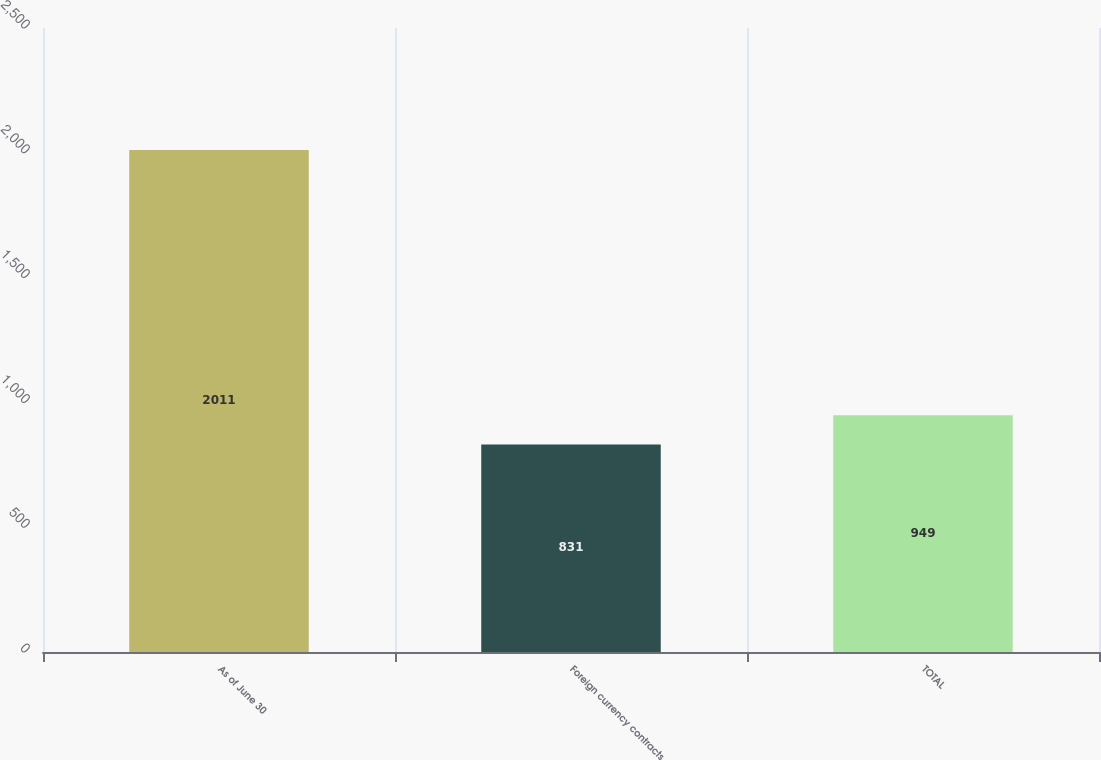Convert chart. <chart><loc_0><loc_0><loc_500><loc_500><bar_chart><fcel>As of June 30<fcel>Foreign currency contracts<fcel>TOTAL<nl><fcel>2011<fcel>831<fcel>949<nl></chart> 